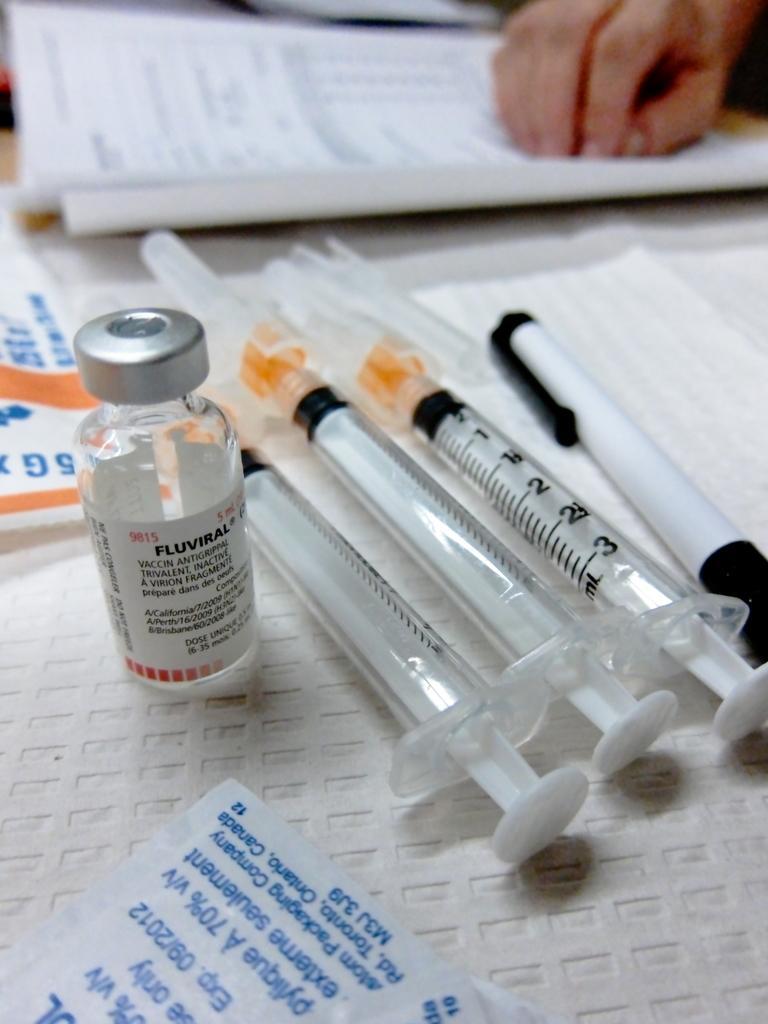Could you give a brief overview of what you see in this image? In this image we can see syringes, pen, bottle, envelope, papers and a human hand on the white color surface. 